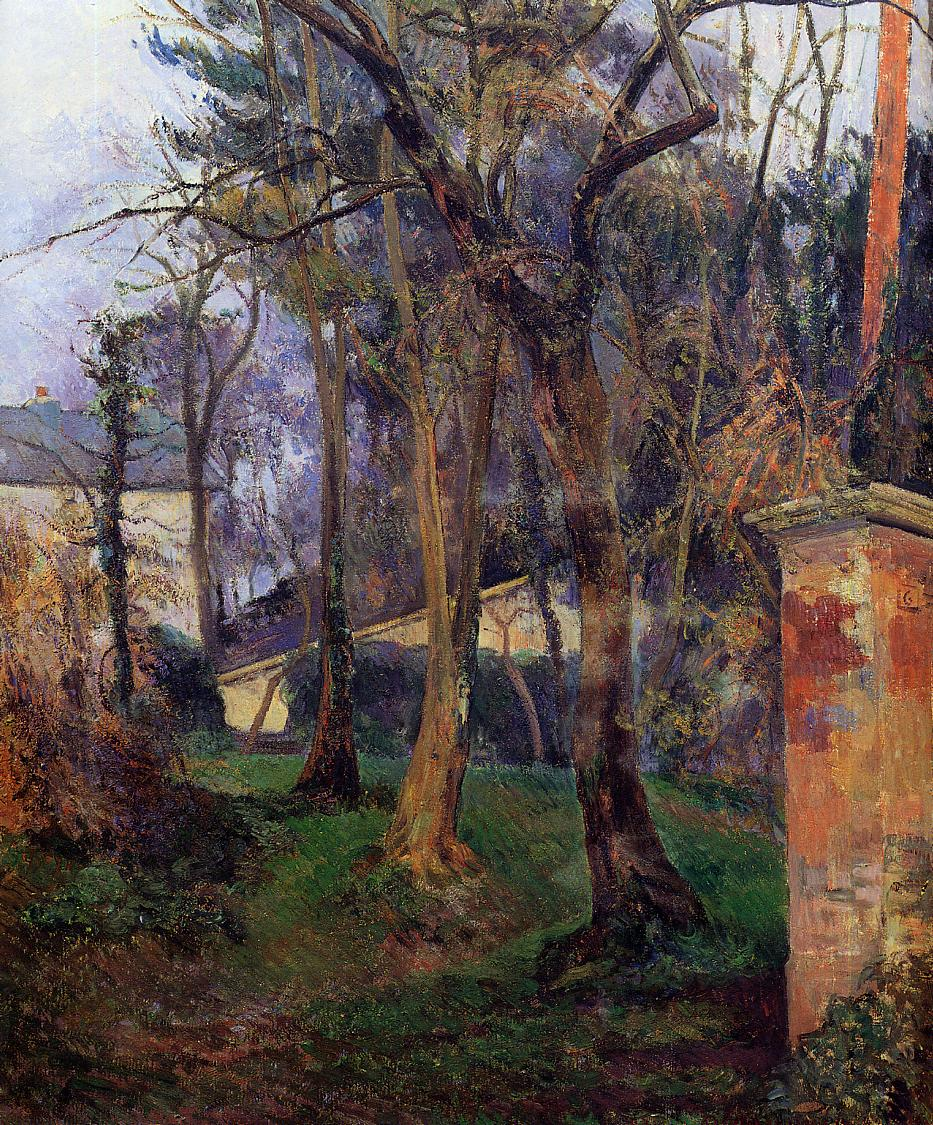How does the artist's style influence your perception of the scene? The impressionist technique used in this painting, with its loose, expressive brushstrokes, enhances the dynamic quality of the natural scene. This style emphasizes the transient effects of light and color, making the landscape appear alive and in constant flux. Rather than providing a detailed, realistic depiction, this approach allows the scene to resonate on a more emotional level, giving viewers space to engage their imagination and personal interpretations. 